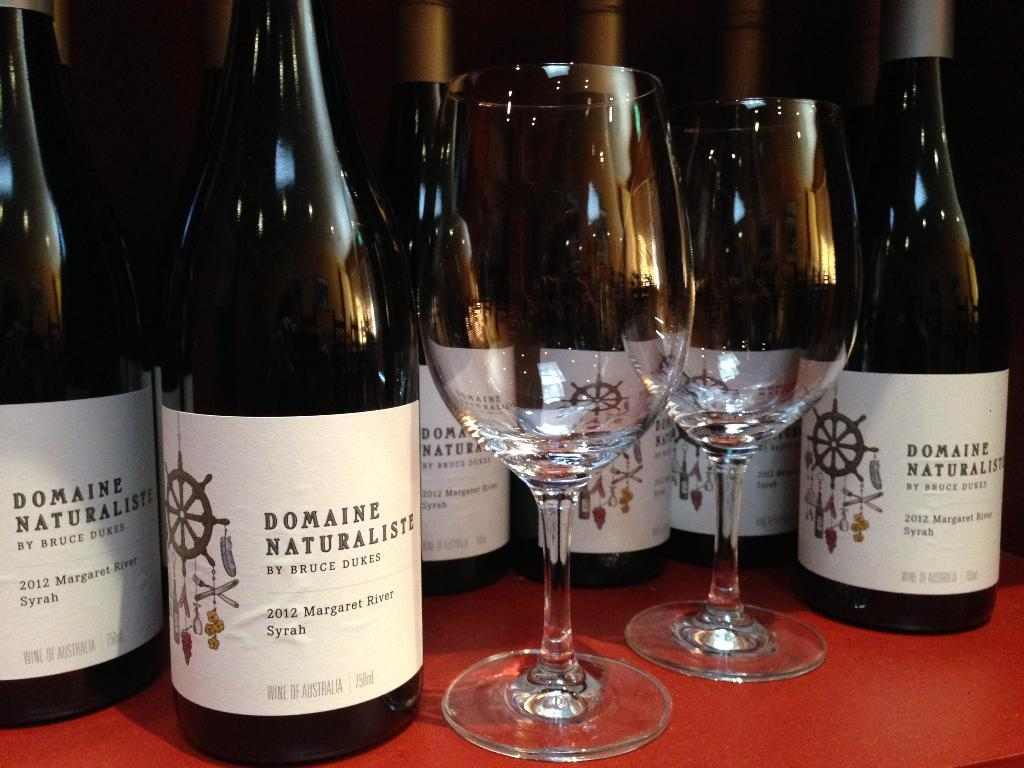What objects are present in the image that are typically associated with drinking? There are bottles and two wine glasses in the image. What might the red object be that the wine glasses and bottles are on? The provided facts do not specify the nature of the red object, but it is clear that the wine glasses and bottles are placed on it. What type of office experience can be seen in the image? There is no reference to an office or any experience in the image, as it features bottles and wine glasses on a red object. 